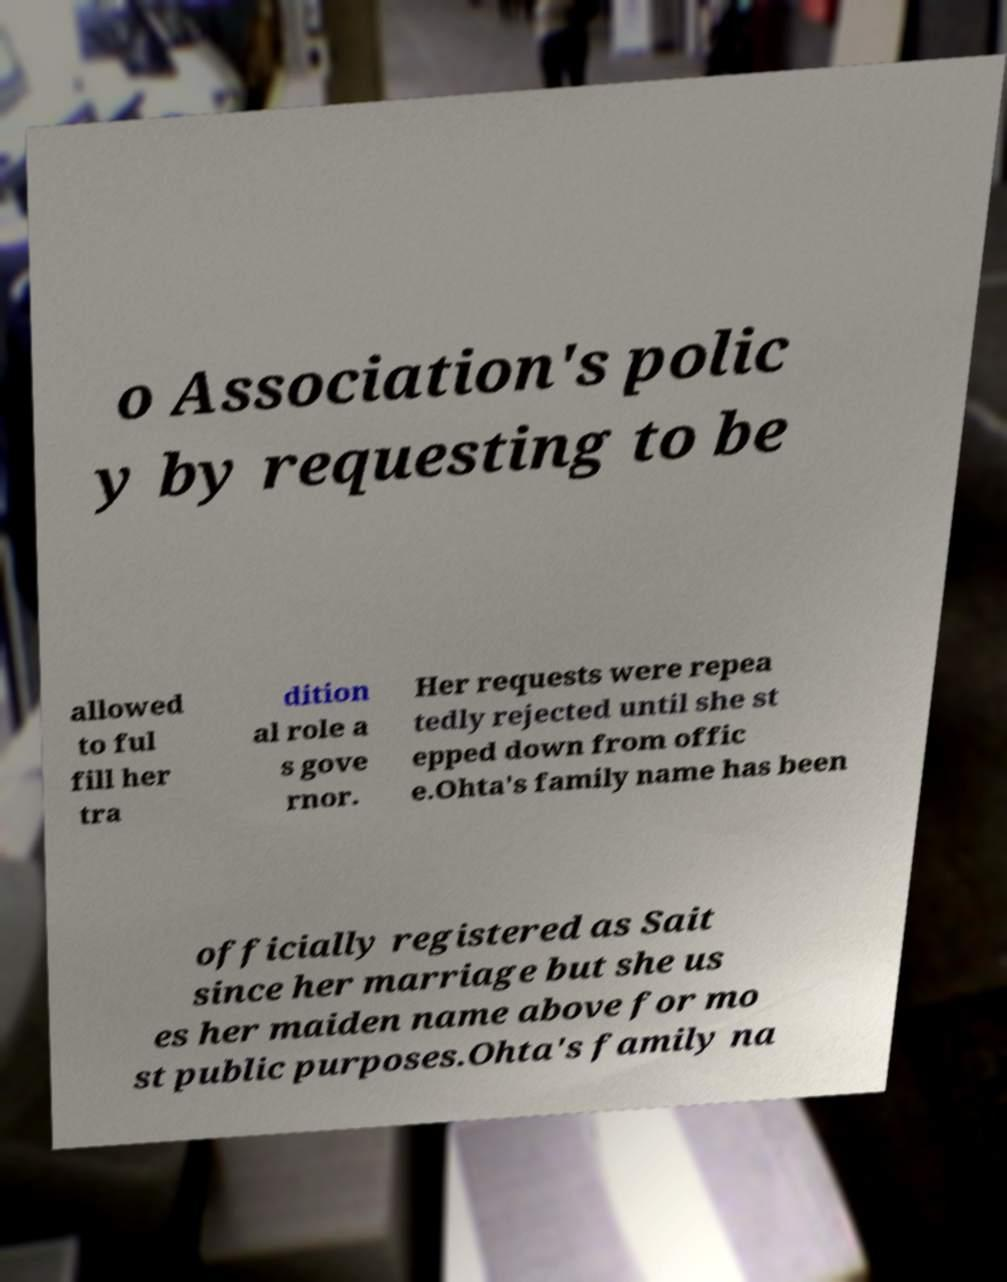For documentation purposes, I need the text within this image transcribed. Could you provide that? o Association's polic y by requesting to be allowed to ful fill her tra dition al role a s gove rnor. Her requests were repea tedly rejected until she st epped down from offic e.Ohta's family name has been officially registered as Sait since her marriage but she us es her maiden name above for mo st public purposes.Ohta's family na 